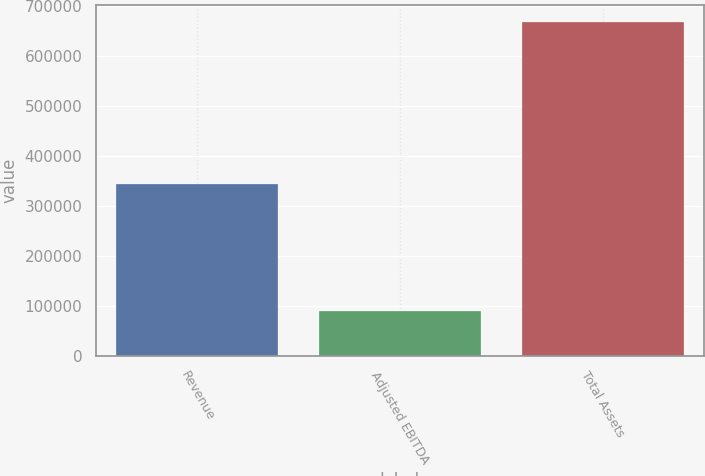Convert chart to OTSL. <chart><loc_0><loc_0><loc_500><loc_500><bar_chart><fcel>Revenue<fcel>Adjusted EBITDA<fcel>Total Assets<nl><fcel>343969<fcel>90018<fcel>668555<nl></chart> 